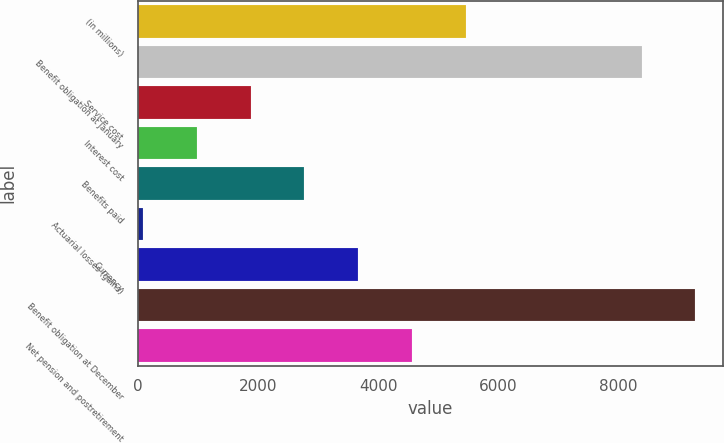Convert chart to OTSL. <chart><loc_0><loc_0><loc_500><loc_500><bar_chart><fcel>(in millions)<fcel>Benefit obligation at January<fcel>Service cost<fcel>Interest cost<fcel>Benefits paid<fcel>Actuarial losses (gains)<fcel>Currency<fcel>Benefit obligation at December<fcel>Net pension and postretirement<nl><fcel>5454<fcel>8387<fcel>1880<fcel>986.5<fcel>2773.5<fcel>93<fcel>3667<fcel>9280.5<fcel>4560.5<nl></chart> 